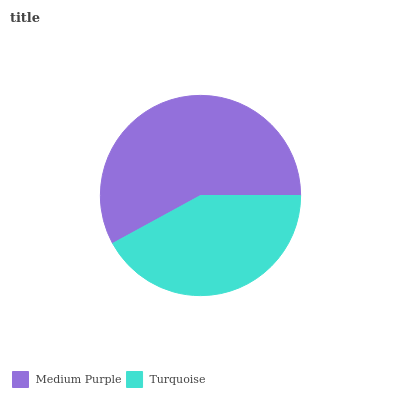Is Turquoise the minimum?
Answer yes or no. Yes. Is Medium Purple the maximum?
Answer yes or no. Yes. Is Turquoise the maximum?
Answer yes or no. No. Is Medium Purple greater than Turquoise?
Answer yes or no. Yes. Is Turquoise less than Medium Purple?
Answer yes or no. Yes. Is Turquoise greater than Medium Purple?
Answer yes or no. No. Is Medium Purple less than Turquoise?
Answer yes or no. No. Is Medium Purple the high median?
Answer yes or no. Yes. Is Turquoise the low median?
Answer yes or no. Yes. Is Turquoise the high median?
Answer yes or no. No. Is Medium Purple the low median?
Answer yes or no. No. 